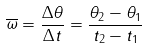<formula> <loc_0><loc_0><loc_500><loc_500>\overline { \omega } = \frac { \Delta \theta } { \Delta t } = \frac { \theta _ { 2 } - \theta _ { 1 } } { t _ { 2 } - t _ { 1 } }</formula> 